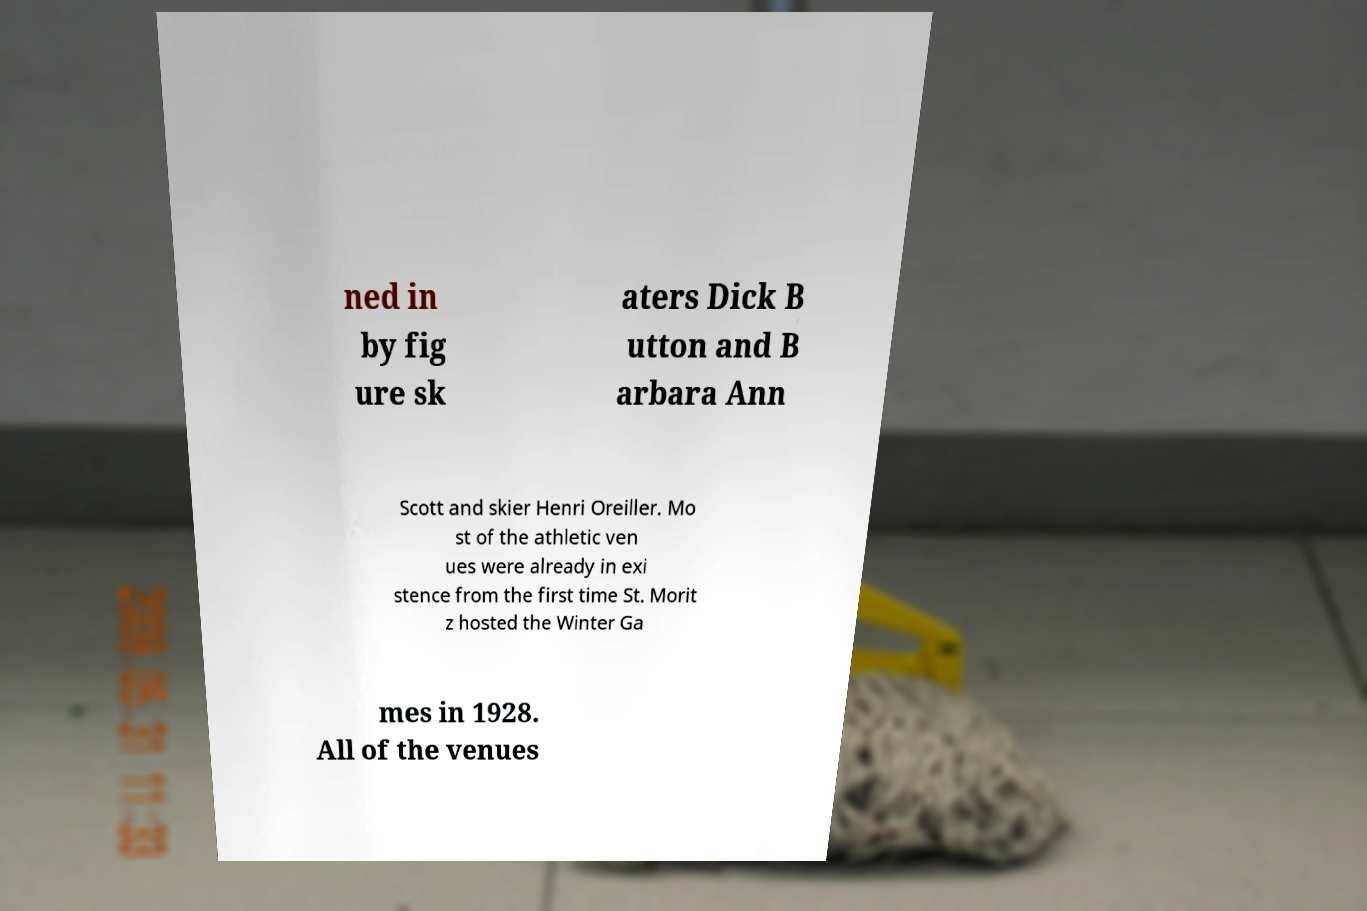I need the written content from this picture converted into text. Can you do that? ned in by fig ure sk aters Dick B utton and B arbara Ann Scott and skier Henri Oreiller. Mo st of the athletic ven ues were already in exi stence from the first time St. Morit z hosted the Winter Ga mes in 1928. All of the venues 